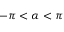Convert formula to latex. <formula><loc_0><loc_0><loc_500><loc_500>- \pi < \alpha < \pi</formula> 